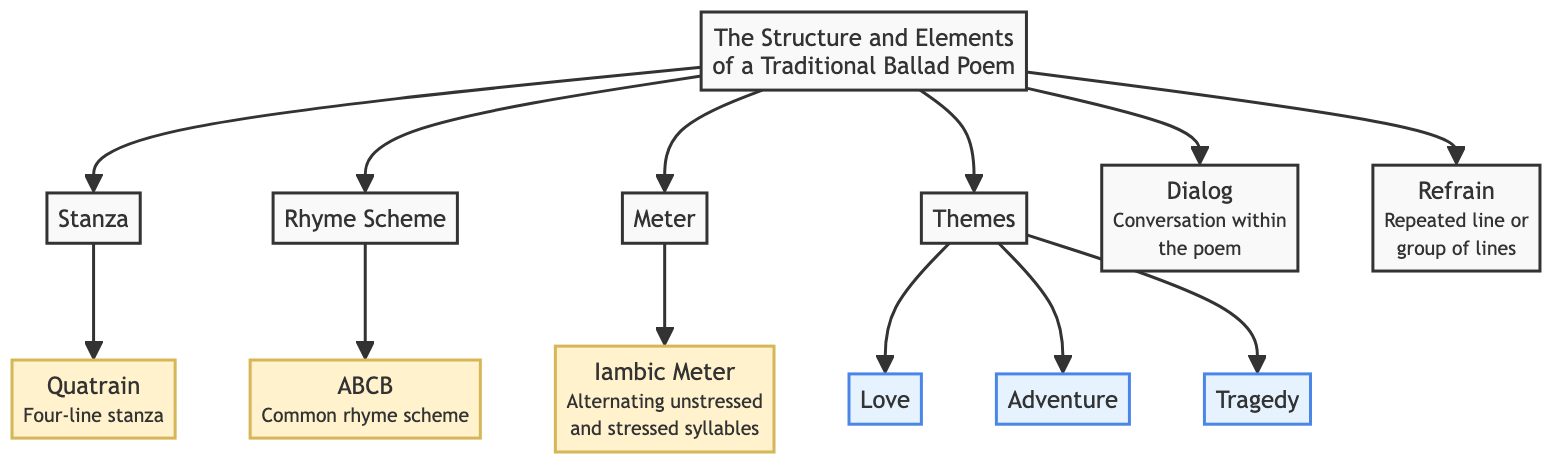What are the elements of a traditional ballad poem? The diagram indicates that the elements of a traditional ballad poem include Stanza, Rhyme Scheme, Meter, Themes, Dialog, and Refrain. Each element is a node connected to the main node, which is the structure and elements of a traditional ballad poem.
Answer: Stanza, Rhyme Scheme, Meter, Themes, Dialog, Refrain How many themes are listed in the diagram? The diagram lists three themes: Love, Adventure, and Tragedy. These are represented as nodes under the main theme node, indicating there are three distinct themes associated with traditional ballads.
Answer: 3 What is the rhyme scheme used in a traditional ballad poem? The diagram specifies that the common rhyme scheme in traditional ballads is ABCB. This is shown as a direct connection to the Rhyme Scheme element in the diagram.
Answer: ABCB What type of stanza is used in traditional ballads? The diagram indicates that the type of stanza used is a Quatrain. This is specifically detailed in the sub-node connected to the Stanza node, defining it as a four-line stanza.
Answer: Quatrain What meter is typically found in traditional ballads? According to the diagram, the meter typically found in traditional ballads is Iambic Meter. This is connected directly to the Meter node, defining the rhythmic structure of the poem.
Answer: Iambic Meter What does the Refrain in a traditional ballad poem represent? The diagram notes that the Refrain consists of a repeated line or group of lines. This is specified in the description within the Refrain node, indicating its function in the poem.
Answer: Repeated line or group of lines Which element allows for dialogue within the ballad? The diagram points out that the element allowing for dialogue within the ballad is Dialog. This is explicitly mentioned under the corresponding node in the diagram, showing its inclusion in the structure.
Answer: Dialog How many lines are typically in a Quatrain? The diagram clarifies that a Quatrain consists of four lines, as indicated in the descriptive text within the Quatrain node connecting back to the Stanza element.
Answer: Four lines What are the three themes listed in the diagram? By examining the diagram, we see the themes are specifically stated as Love, Adventure, and Tragedy. Each of these themes is directly connected as nodes under the Themes element in the diagram.
Answer: Love, Adventure, Tragedy 